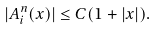<formula> <loc_0><loc_0><loc_500><loc_500>| A ^ { n } _ { i } ( x ) | \leq C ( 1 + | x | ) .</formula> 